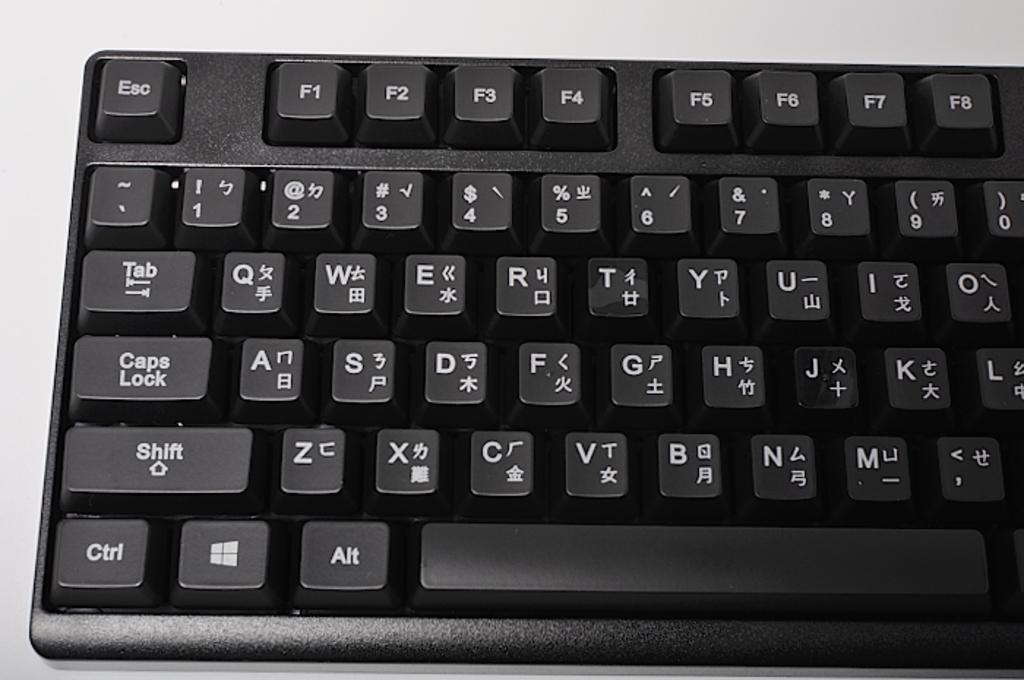What is one of the keys called on this keyboard?
Provide a succinct answer. Caps lock. What type of key is on the top left of the first row?
Your response must be concise. Esc. 